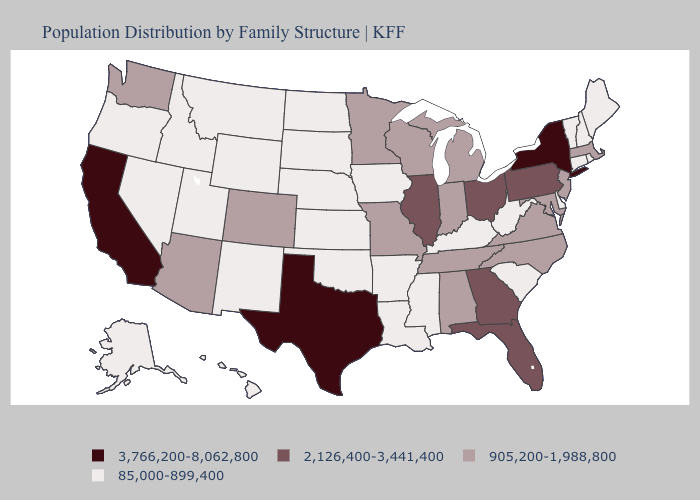What is the value of Wyoming?
Concise answer only. 85,000-899,400. Name the states that have a value in the range 905,200-1,988,800?
Keep it brief. Alabama, Arizona, Colorado, Indiana, Maryland, Massachusetts, Michigan, Minnesota, Missouri, New Jersey, North Carolina, Tennessee, Virginia, Washington, Wisconsin. Does the first symbol in the legend represent the smallest category?
Be succinct. No. Which states have the highest value in the USA?
Be succinct. California, New York, Texas. What is the highest value in the USA?
Keep it brief. 3,766,200-8,062,800. What is the value of Utah?
Answer briefly. 85,000-899,400. Does Alabama have the lowest value in the USA?
Answer briefly. No. Does the first symbol in the legend represent the smallest category?
Quick response, please. No. Does the first symbol in the legend represent the smallest category?
Keep it brief. No. Name the states that have a value in the range 85,000-899,400?
Give a very brief answer. Alaska, Arkansas, Connecticut, Delaware, Hawaii, Idaho, Iowa, Kansas, Kentucky, Louisiana, Maine, Mississippi, Montana, Nebraska, Nevada, New Hampshire, New Mexico, North Dakota, Oklahoma, Oregon, Rhode Island, South Carolina, South Dakota, Utah, Vermont, West Virginia, Wyoming. Among the states that border Wyoming , which have the highest value?
Answer briefly. Colorado. What is the value of Michigan?
Keep it brief. 905,200-1,988,800. Name the states that have a value in the range 905,200-1,988,800?
Keep it brief. Alabama, Arizona, Colorado, Indiana, Maryland, Massachusetts, Michigan, Minnesota, Missouri, New Jersey, North Carolina, Tennessee, Virginia, Washington, Wisconsin. Which states hav the highest value in the Northeast?
Quick response, please. New York. Which states have the lowest value in the USA?
Quick response, please. Alaska, Arkansas, Connecticut, Delaware, Hawaii, Idaho, Iowa, Kansas, Kentucky, Louisiana, Maine, Mississippi, Montana, Nebraska, Nevada, New Hampshire, New Mexico, North Dakota, Oklahoma, Oregon, Rhode Island, South Carolina, South Dakota, Utah, Vermont, West Virginia, Wyoming. 